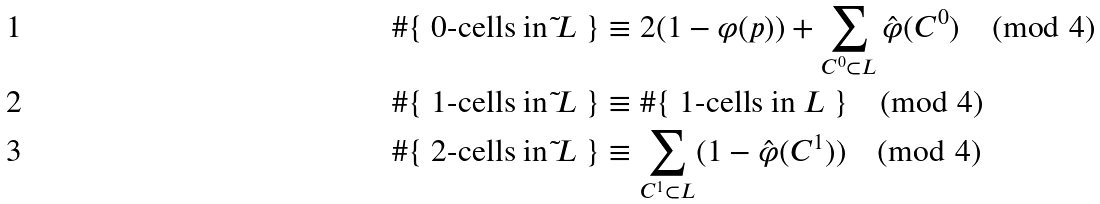Convert formula to latex. <formula><loc_0><loc_0><loc_500><loc_500>& \# \{ \text { 0-cells in $\tilde{ }L$ } \} \equiv 2 ( 1 - \varphi ( p ) ) + \sum _ { C ^ { 0 } \subset L } \hat { \varphi } ( C ^ { 0 } ) \pmod { 4 } \\ & \# \{ \text { 1-cells in $\tilde{ }L$ } \} \equiv \# \{ \text { 1-cells in $L$ } \} \pmod { 4 } \\ & \# \{ \text { 2-cells in $\tilde{ }L$ } \} \equiv \sum _ { C ^ { 1 } \subset L } ( 1 - \hat { \varphi } ( C ^ { 1 } ) ) \pmod { 4 }</formula> 